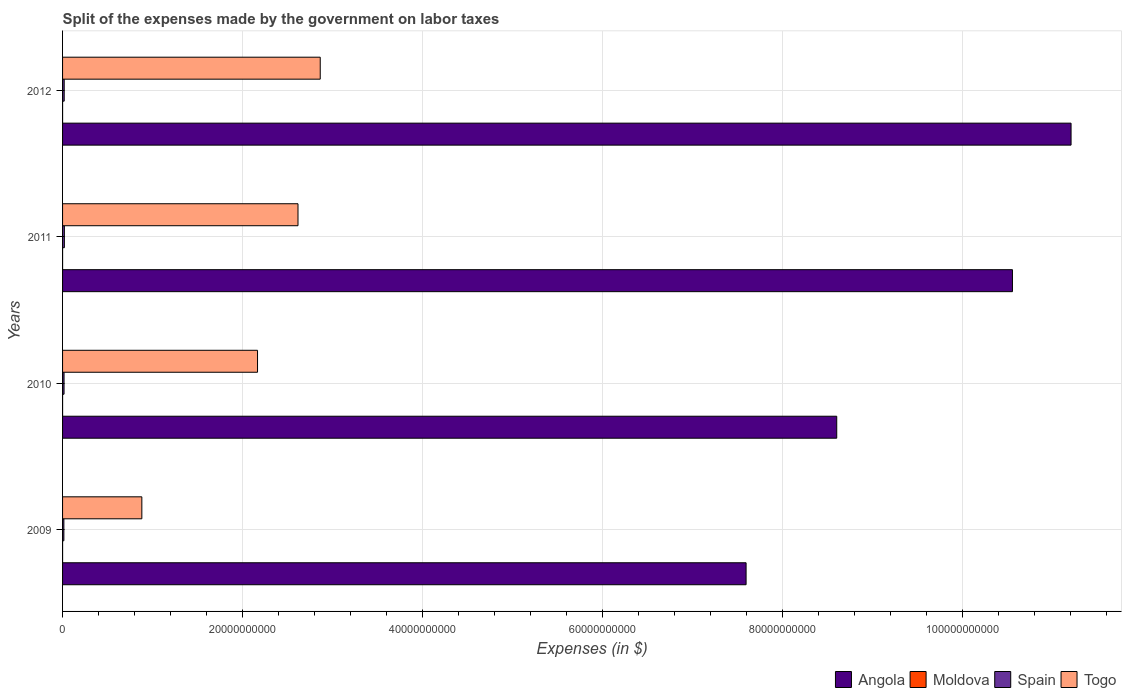How many different coloured bars are there?
Your answer should be very brief. 4. Are the number of bars per tick equal to the number of legend labels?
Offer a terse response. Yes. What is the label of the 1st group of bars from the top?
Provide a succinct answer. 2012. What is the expenses made by the government on labor taxes in Moldova in 2012?
Offer a terse response. 1.30e+06. Across all years, what is the maximum expenses made by the government on labor taxes in Angola?
Keep it short and to the point. 1.12e+11. Across all years, what is the minimum expenses made by the government on labor taxes in Spain?
Make the answer very short. 1.46e+08. In which year was the expenses made by the government on labor taxes in Moldova maximum?
Make the answer very short. 2011. In which year was the expenses made by the government on labor taxes in Angola minimum?
Offer a very short reply. 2009. What is the total expenses made by the government on labor taxes in Togo in the graph?
Keep it short and to the point. 8.52e+1. What is the difference between the expenses made by the government on labor taxes in Spain in 2010 and that in 2011?
Your answer should be compact. -3.60e+07. What is the difference between the expenses made by the government on labor taxes in Spain in 2011 and the expenses made by the government on labor taxes in Angola in 2012?
Your response must be concise. -1.12e+11. What is the average expenses made by the government on labor taxes in Moldova per year?
Make the answer very short. 9.50e+05. In the year 2012, what is the difference between the expenses made by the government on labor taxes in Togo and expenses made by the government on labor taxes in Spain?
Make the answer very short. 2.84e+1. In how many years, is the expenses made by the government on labor taxes in Togo greater than 48000000000 $?
Ensure brevity in your answer.  0. What is the ratio of the expenses made by the government on labor taxes in Angola in 2009 to that in 2012?
Keep it short and to the point. 0.68. Is the difference between the expenses made by the government on labor taxes in Togo in 2011 and 2012 greater than the difference between the expenses made by the government on labor taxes in Spain in 2011 and 2012?
Provide a short and direct response. No. What is the difference between the highest and the second highest expenses made by the government on labor taxes in Togo?
Your response must be concise. 2.47e+09. What is the difference between the highest and the lowest expenses made by the government on labor taxes in Angola?
Your response must be concise. 3.61e+1. In how many years, is the expenses made by the government on labor taxes in Togo greater than the average expenses made by the government on labor taxes in Togo taken over all years?
Make the answer very short. 3. Is it the case that in every year, the sum of the expenses made by the government on labor taxes in Togo and expenses made by the government on labor taxes in Moldova is greater than the sum of expenses made by the government on labor taxes in Spain and expenses made by the government on labor taxes in Angola?
Ensure brevity in your answer.  Yes. What does the 4th bar from the top in 2010 represents?
Your answer should be very brief. Angola. What does the 3rd bar from the bottom in 2012 represents?
Give a very brief answer. Spain. How many bars are there?
Ensure brevity in your answer.  16. How many years are there in the graph?
Offer a terse response. 4. What is the difference between two consecutive major ticks on the X-axis?
Make the answer very short. 2.00e+1. Does the graph contain any zero values?
Provide a succinct answer. No. Does the graph contain grids?
Give a very brief answer. Yes. Where does the legend appear in the graph?
Keep it short and to the point. Bottom right. What is the title of the graph?
Make the answer very short. Split of the expenses made by the government on labor taxes. Does "American Samoa" appear as one of the legend labels in the graph?
Your answer should be compact. No. What is the label or title of the X-axis?
Provide a short and direct response. Expenses (in $). What is the label or title of the Y-axis?
Offer a terse response. Years. What is the Expenses (in $) of Angola in 2009?
Provide a short and direct response. 7.59e+1. What is the Expenses (in $) in Moldova in 2009?
Keep it short and to the point. 5.00e+05. What is the Expenses (in $) in Spain in 2009?
Your answer should be very brief. 1.46e+08. What is the Expenses (in $) in Togo in 2009?
Ensure brevity in your answer.  8.80e+09. What is the Expenses (in $) in Angola in 2010?
Offer a terse response. 8.60e+1. What is the Expenses (in $) of Moldova in 2010?
Provide a short and direct response. 7.00e+05. What is the Expenses (in $) of Spain in 2010?
Provide a short and direct response. 1.65e+08. What is the Expenses (in $) of Togo in 2010?
Ensure brevity in your answer.  2.17e+1. What is the Expenses (in $) of Angola in 2011?
Give a very brief answer. 1.06e+11. What is the Expenses (in $) in Moldova in 2011?
Offer a very short reply. 1.30e+06. What is the Expenses (in $) of Spain in 2011?
Provide a short and direct response. 2.01e+08. What is the Expenses (in $) of Togo in 2011?
Make the answer very short. 2.62e+1. What is the Expenses (in $) in Angola in 2012?
Ensure brevity in your answer.  1.12e+11. What is the Expenses (in $) of Moldova in 2012?
Keep it short and to the point. 1.30e+06. What is the Expenses (in $) in Spain in 2012?
Your response must be concise. 1.82e+08. What is the Expenses (in $) of Togo in 2012?
Your answer should be compact. 2.86e+1. Across all years, what is the maximum Expenses (in $) of Angola?
Ensure brevity in your answer.  1.12e+11. Across all years, what is the maximum Expenses (in $) in Moldova?
Your response must be concise. 1.30e+06. Across all years, what is the maximum Expenses (in $) in Spain?
Ensure brevity in your answer.  2.01e+08. Across all years, what is the maximum Expenses (in $) of Togo?
Provide a succinct answer. 2.86e+1. Across all years, what is the minimum Expenses (in $) of Angola?
Your answer should be compact. 7.59e+1. Across all years, what is the minimum Expenses (in $) in Spain?
Give a very brief answer. 1.46e+08. Across all years, what is the minimum Expenses (in $) in Togo?
Make the answer very short. 8.80e+09. What is the total Expenses (in $) in Angola in the graph?
Keep it short and to the point. 3.79e+11. What is the total Expenses (in $) in Moldova in the graph?
Provide a short and direct response. 3.80e+06. What is the total Expenses (in $) in Spain in the graph?
Offer a very short reply. 6.94e+08. What is the total Expenses (in $) in Togo in the graph?
Provide a succinct answer. 8.52e+1. What is the difference between the Expenses (in $) in Angola in 2009 and that in 2010?
Make the answer very short. -1.01e+1. What is the difference between the Expenses (in $) in Moldova in 2009 and that in 2010?
Your answer should be compact. -2.00e+05. What is the difference between the Expenses (in $) of Spain in 2009 and that in 2010?
Make the answer very short. -1.90e+07. What is the difference between the Expenses (in $) of Togo in 2009 and that in 2010?
Your response must be concise. -1.28e+1. What is the difference between the Expenses (in $) in Angola in 2009 and that in 2011?
Give a very brief answer. -2.96e+1. What is the difference between the Expenses (in $) of Moldova in 2009 and that in 2011?
Give a very brief answer. -8.00e+05. What is the difference between the Expenses (in $) in Spain in 2009 and that in 2011?
Offer a very short reply. -5.50e+07. What is the difference between the Expenses (in $) of Togo in 2009 and that in 2011?
Keep it short and to the point. -1.73e+1. What is the difference between the Expenses (in $) in Angola in 2009 and that in 2012?
Offer a very short reply. -3.61e+1. What is the difference between the Expenses (in $) of Moldova in 2009 and that in 2012?
Your answer should be compact. -8.00e+05. What is the difference between the Expenses (in $) in Spain in 2009 and that in 2012?
Your response must be concise. -3.60e+07. What is the difference between the Expenses (in $) in Togo in 2009 and that in 2012?
Provide a succinct answer. -1.98e+1. What is the difference between the Expenses (in $) of Angola in 2010 and that in 2011?
Provide a succinct answer. -1.95e+1. What is the difference between the Expenses (in $) in Moldova in 2010 and that in 2011?
Keep it short and to the point. -6.00e+05. What is the difference between the Expenses (in $) in Spain in 2010 and that in 2011?
Offer a very short reply. -3.60e+07. What is the difference between the Expenses (in $) in Togo in 2010 and that in 2011?
Offer a terse response. -4.50e+09. What is the difference between the Expenses (in $) in Angola in 2010 and that in 2012?
Ensure brevity in your answer.  -2.60e+1. What is the difference between the Expenses (in $) of Moldova in 2010 and that in 2012?
Your answer should be very brief. -6.00e+05. What is the difference between the Expenses (in $) of Spain in 2010 and that in 2012?
Make the answer very short. -1.70e+07. What is the difference between the Expenses (in $) in Togo in 2010 and that in 2012?
Provide a succinct answer. -6.97e+09. What is the difference between the Expenses (in $) of Angola in 2011 and that in 2012?
Keep it short and to the point. -6.51e+09. What is the difference between the Expenses (in $) in Spain in 2011 and that in 2012?
Your answer should be compact. 1.90e+07. What is the difference between the Expenses (in $) in Togo in 2011 and that in 2012?
Keep it short and to the point. -2.47e+09. What is the difference between the Expenses (in $) of Angola in 2009 and the Expenses (in $) of Moldova in 2010?
Offer a very short reply. 7.59e+1. What is the difference between the Expenses (in $) in Angola in 2009 and the Expenses (in $) in Spain in 2010?
Keep it short and to the point. 7.58e+1. What is the difference between the Expenses (in $) in Angola in 2009 and the Expenses (in $) in Togo in 2010?
Provide a succinct answer. 5.43e+1. What is the difference between the Expenses (in $) of Moldova in 2009 and the Expenses (in $) of Spain in 2010?
Make the answer very short. -1.64e+08. What is the difference between the Expenses (in $) of Moldova in 2009 and the Expenses (in $) of Togo in 2010?
Offer a terse response. -2.17e+1. What is the difference between the Expenses (in $) in Spain in 2009 and the Expenses (in $) in Togo in 2010?
Give a very brief answer. -2.15e+1. What is the difference between the Expenses (in $) in Angola in 2009 and the Expenses (in $) in Moldova in 2011?
Offer a very short reply. 7.59e+1. What is the difference between the Expenses (in $) of Angola in 2009 and the Expenses (in $) of Spain in 2011?
Give a very brief answer. 7.57e+1. What is the difference between the Expenses (in $) of Angola in 2009 and the Expenses (in $) of Togo in 2011?
Ensure brevity in your answer.  4.98e+1. What is the difference between the Expenses (in $) in Moldova in 2009 and the Expenses (in $) in Spain in 2011?
Ensure brevity in your answer.  -2.00e+08. What is the difference between the Expenses (in $) of Moldova in 2009 and the Expenses (in $) of Togo in 2011?
Your response must be concise. -2.61e+1. What is the difference between the Expenses (in $) in Spain in 2009 and the Expenses (in $) in Togo in 2011?
Keep it short and to the point. -2.60e+1. What is the difference between the Expenses (in $) of Angola in 2009 and the Expenses (in $) of Moldova in 2012?
Give a very brief answer. 7.59e+1. What is the difference between the Expenses (in $) of Angola in 2009 and the Expenses (in $) of Spain in 2012?
Give a very brief answer. 7.57e+1. What is the difference between the Expenses (in $) in Angola in 2009 and the Expenses (in $) in Togo in 2012?
Provide a succinct answer. 4.73e+1. What is the difference between the Expenses (in $) of Moldova in 2009 and the Expenses (in $) of Spain in 2012?
Offer a terse response. -1.82e+08. What is the difference between the Expenses (in $) in Moldova in 2009 and the Expenses (in $) in Togo in 2012?
Make the answer very short. -2.86e+1. What is the difference between the Expenses (in $) of Spain in 2009 and the Expenses (in $) of Togo in 2012?
Keep it short and to the point. -2.85e+1. What is the difference between the Expenses (in $) in Angola in 2010 and the Expenses (in $) in Moldova in 2011?
Give a very brief answer. 8.60e+1. What is the difference between the Expenses (in $) in Angola in 2010 and the Expenses (in $) in Spain in 2011?
Give a very brief answer. 8.58e+1. What is the difference between the Expenses (in $) of Angola in 2010 and the Expenses (in $) of Togo in 2011?
Offer a very short reply. 5.98e+1. What is the difference between the Expenses (in $) of Moldova in 2010 and the Expenses (in $) of Spain in 2011?
Offer a very short reply. -2.00e+08. What is the difference between the Expenses (in $) of Moldova in 2010 and the Expenses (in $) of Togo in 2011?
Keep it short and to the point. -2.61e+1. What is the difference between the Expenses (in $) of Spain in 2010 and the Expenses (in $) of Togo in 2011?
Your response must be concise. -2.60e+1. What is the difference between the Expenses (in $) of Angola in 2010 and the Expenses (in $) of Moldova in 2012?
Provide a short and direct response. 8.60e+1. What is the difference between the Expenses (in $) in Angola in 2010 and the Expenses (in $) in Spain in 2012?
Make the answer very short. 8.58e+1. What is the difference between the Expenses (in $) in Angola in 2010 and the Expenses (in $) in Togo in 2012?
Provide a short and direct response. 5.74e+1. What is the difference between the Expenses (in $) in Moldova in 2010 and the Expenses (in $) in Spain in 2012?
Your answer should be compact. -1.81e+08. What is the difference between the Expenses (in $) in Moldova in 2010 and the Expenses (in $) in Togo in 2012?
Give a very brief answer. -2.86e+1. What is the difference between the Expenses (in $) in Spain in 2010 and the Expenses (in $) in Togo in 2012?
Make the answer very short. -2.85e+1. What is the difference between the Expenses (in $) of Angola in 2011 and the Expenses (in $) of Moldova in 2012?
Ensure brevity in your answer.  1.06e+11. What is the difference between the Expenses (in $) of Angola in 2011 and the Expenses (in $) of Spain in 2012?
Keep it short and to the point. 1.05e+11. What is the difference between the Expenses (in $) of Angola in 2011 and the Expenses (in $) of Togo in 2012?
Your answer should be very brief. 7.69e+1. What is the difference between the Expenses (in $) in Moldova in 2011 and the Expenses (in $) in Spain in 2012?
Give a very brief answer. -1.81e+08. What is the difference between the Expenses (in $) of Moldova in 2011 and the Expenses (in $) of Togo in 2012?
Offer a very short reply. -2.86e+1. What is the difference between the Expenses (in $) in Spain in 2011 and the Expenses (in $) in Togo in 2012?
Keep it short and to the point. -2.84e+1. What is the average Expenses (in $) of Angola per year?
Offer a terse response. 9.49e+1. What is the average Expenses (in $) in Moldova per year?
Your answer should be very brief. 9.50e+05. What is the average Expenses (in $) in Spain per year?
Provide a succinct answer. 1.74e+08. What is the average Expenses (in $) in Togo per year?
Provide a short and direct response. 2.13e+1. In the year 2009, what is the difference between the Expenses (in $) in Angola and Expenses (in $) in Moldova?
Your response must be concise. 7.59e+1. In the year 2009, what is the difference between the Expenses (in $) of Angola and Expenses (in $) of Spain?
Provide a short and direct response. 7.58e+1. In the year 2009, what is the difference between the Expenses (in $) of Angola and Expenses (in $) of Togo?
Keep it short and to the point. 6.71e+1. In the year 2009, what is the difference between the Expenses (in $) of Moldova and Expenses (in $) of Spain?
Ensure brevity in your answer.  -1.46e+08. In the year 2009, what is the difference between the Expenses (in $) of Moldova and Expenses (in $) of Togo?
Keep it short and to the point. -8.80e+09. In the year 2009, what is the difference between the Expenses (in $) in Spain and Expenses (in $) in Togo?
Provide a succinct answer. -8.66e+09. In the year 2010, what is the difference between the Expenses (in $) in Angola and Expenses (in $) in Moldova?
Make the answer very short. 8.60e+1. In the year 2010, what is the difference between the Expenses (in $) of Angola and Expenses (in $) of Spain?
Provide a short and direct response. 8.58e+1. In the year 2010, what is the difference between the Expenses (in $) of Angola and Expenses (in $) of Togo?
Your response must be concise. 6.43e+1. In the year 2010, what is the difference between the Expenses (in $) in Moldova and Expenses (in $) in Spain?
Your answer should be very brief. -1.64e+08. In the year 2010, what is the difference between the Expenses (in $) of Moldova and Expenses (in $) of Togo?
Your answer should be very brief. -2.17e+1. In the year 2010, what is the difference between the Expenses (in $) in Spain and Expenses (in $) in Togo?
Give a very brief answer. -2.15e+1. In the year 2011, what is the difference between the Expenses (in $) in Angola and Expenses (in $) in Moldova?
Offer a very short reply. 1.06e+11. In the year 2011, what is the difference between the Expenses (in $) of Angola and Expenses (in $) of Spain?
Give a very brief answer. 1.05e+11. In the year 2011, what is the difference between the Expenses (in $) of Angola and Expenses (in $) of Togo?
Give a very brief answer. 7.94e+1. In the year 2011, what is the difference between the Expenses (in $) of Moldova and Expenses (in $) of Spain?
Offer a terse response. -2.00e+08. In the year 2011, what is the difference between the Expenses (in $) in Moldova and Expenses (in $) in Togo?
Your answer should be compact. -2.61e+1. In the year 2011, what is the difference between the Expenses (in $) in Spain and Expenses (in $) in Togo?
Offer a very short reply. -2.59e+1. In the year 2012, what is the difference between the Expenses (in $) of Angola and Expenses (in $) of Moldova?
Keep it short and to the point. 1.12e+11. In the year 2012, what is the difference between the Expenses (in $) of Angola and Expenses (in $) of Spain?
Make the answer very short. 1.12e+11. In the year 2012, what is the difference between the Expenses (in $) of Angola and Expenses (in $) of Togo?
Your answer should be compact. 8.34e+1. In the year 2012, what is the difference between the Expenses (in $) of Moldova and Expenses (in $) of Spain?
Provide a short and direct response. -1.81e+08. In the year 2012, what is the difference between the Expenses (in $) in Moldova and Expenses (in $) in Togo?
Offer a very short reply. -2.86e+1. In the year 2012, what is the difference between the Expenses (in $) in Spain and Expenses (in $) in Togo?
Offer a terse response. -2.84e+1. What is the ratio of the Expenses (in $) of Angola in 2009 to that in 2010?
Provide a succinct answer. 0.88. What is the ratio of the Expenses (in $) in Moldova in 2009 to that in 2010?
Ensure brevity in your answer.  0.71. What is the ratio of the Expenses (in $) of Spain in 2009 to that in 2010?
Provide a short and direct response. 0.88. What is the ratio of the Expenses (in $) of Togo in 2009 to that in 2010?
Your answer should be compact. 0.41. What is the ratio of the Expenses (in $) in Angola in 2009 to that in 2011?
Make the answer very short. 0.72. What is the ratio of the Expenses (in $) of Moldova in 2009 to that in 2011?
Give a very brief answer. 0.38. What is the ratio of the Expenses (in $) in Spain in 2009 to that in 2011?
Your response must be concise. 0.73. What is the ratio of the Expenses (in $) of Togo in 2009 to that in 2011?
Give a very brief answer. 0.34. What is the ratio of the Expenses (in $) of Angola in 2009 to that in 2012?
Ensure brevity in your answer.  0.68. What is the ratio of the Expenses (in $) in Moldova in 2009 to that in 2012?
Your response must be concise. 0.38. What is the ratio of the Expenses (in $) of Spain in 2009 to that in 2012?
Provide a succinct answer. 0.8. What is the ratio of the Expenses (in $) of Togo in 2009 to that in 2012?
Offer a terse response. 0.31. What is the ratio of the Expenses (in $) in Angola in 2010 to that in 2011?
Your response must be concise. 0.81. What is the ratio of the Expenses (in $) of Moldova in 2010 to that in 2011?
Your response must be concise. 0.54. What is the ratio of the Expenses (in $) in Spain in 2010 to that in 2011?
Ensure brevity in your answer.  0.82. What is the ratio of the Expenses (in $) of Togo in 2010 to that in 2011?
Your answer should be very brief. 0.83. What is the ratio of the Expenses (in $) in Angola in 2010 to that in 2012?
Offer a very short reply. 0.77. What is the ratio of the Expenses (in $) in Moldova in 2010 to that in 2012?
Provide a succinct answer. 0.54. What is the ratio of the Expenses (in $) in Spain in 2010 to that in 2012?
Give a very brief answer. 0.91. What is the ratio of the Expenses (in $) of Togo in 2010 to that in 2012?
Offer a terse response. 0.76. What is the ratio of the Expenses (in $) in Angola in 2011 to that in 2012?
Offer a terse response. 0.94. What is the ratio of the Expenses (in $) in Spain in 2011 to that in 2012?
Give a very brief answer. 1.1. What is the ratio of the Expenses (in $) of Togo in 2011 to that in 2012?
Keep it short and to the point. 0.91. What is the difference between the highest and the second highest Expenses (in $) of Angola?
Ensure brevity in your answer.  6.51e+09. What is the difference between the highest and the second highest Expenses (in $) of Spain?
Give a very brief answer. 1.90e+07. What is the difference between the highest and the second highest Expenses (in $) of Togo?
Ensure brevity in your answer.  2.47e+09. What is the difference between the highest and the lowest Expenses (in $) of Angola?
Your answer should be compact. 3.61e+1. What is the difference between the highest and the lowest Expenses (in $) of Moldova?
Offer a very short reply. 8.00e+05. What is the difference between the highest and the lowest Expenses (in $) in Spain?
Give a very brief answer. 5.50e+07. What is the difference between the highest and the lowest Expenses (in $) in Togo?
Make the answer very short. 1.98e+1. 